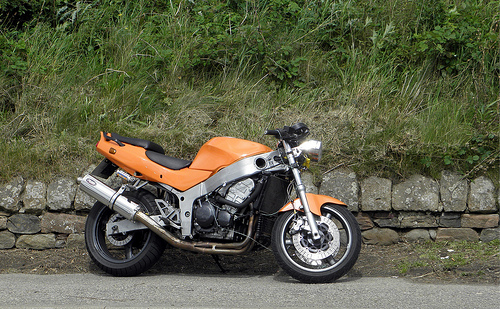<image>
Is there a bike in the rock? No. The bike is not contained within the rock. These objects have a different spatial relationship. Is the bike above the street? No. The bike is not positioned above the street. The vertical arrangement shows a different relationship. 